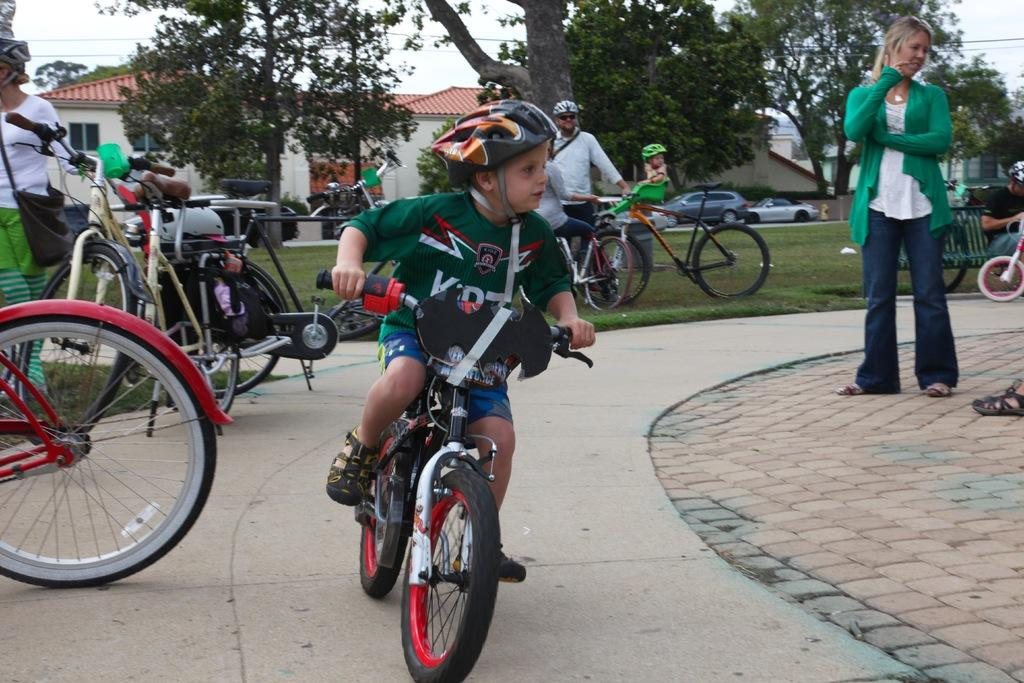What can be seen in the image that people might walk or ride on? There is a path in the image that people might walk or ride on. What are the people using to ride on the path? There are bicycles on the path, and a boy is riding one of them. What type of vegetation is visible in the background of the image? There is grass in the background of the image, as well as trees. What structures can be seen in the background of the image? There is a house and the sky visible in the background of the image. What type of shade is being used by the boy riding the bicycle in the image? There is no mention of shade in the image. The boy is riding a bicycle on a path, and there is no indication of any shade being used. 